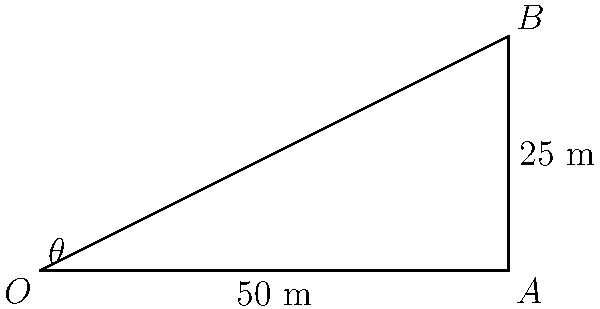In a ballistics investigation, a bullet is fired from point $O$ and hits a target at point $B$. The horizontal distance from the firing point to the target is $50$ meters, and the vertical height of the target is $25$ meters. Assuming the bullet travels in a straight line, what is the angle $\theta$ (in degrees) at which the bullet was fired? To solve this problem, we'll use trigonometry, specifically the tangent function.

1) First, let's identify the right triangle in the diagram:
   - The horizontal distance ($OA$) is the adjacent side to angle $\theta$.
   - The vertical height ($AB$) is the opposite side to angle $\theta$.

2) We know that:
   - Adjacent side (OA) = 50 meters
   - Opposite side (AB) = 25 meters

3) The tangent of an angle is defined as the ratio of the opposite side to the adjacent side:

   $$\tan(\theta) = \frac{\text{opposite}}{\text{adjacent}} = \frac{AB}{OA}$$

4) Substituting our known values:

   $$\tan(\theta) = \frac{25}{50} = 0.5$$

5) To find $\theta$, we need to use the inverse tangent (arctan or $\tan^{-1}$):

   $$\theta = \tan^{-1}(0.5)$$

6) Using a calculator or trigonometric tables:

   $$\theta \approx 26.57^{\circ}$$

Therefore, the bullet was fired at an angle of approximately 26.57 degrees.
Answer: $26.57^{\circ}$ 